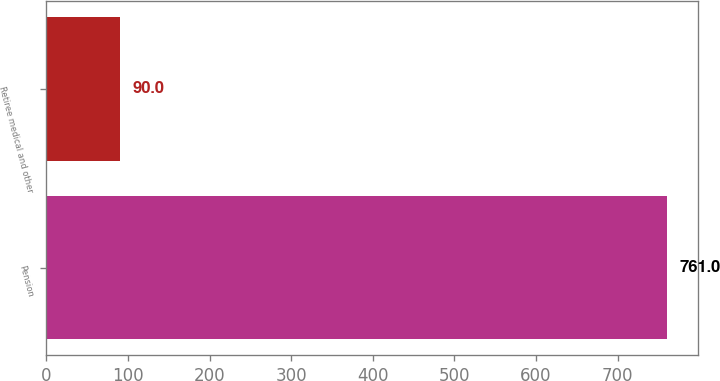Convert chart. <chart><loc_0><loc_0><loc_500><loc_500><bar_chart><fcel>Pension<fcel>Retiree medical and other<nl><fcel>761<fcel>90<nl></chart> 